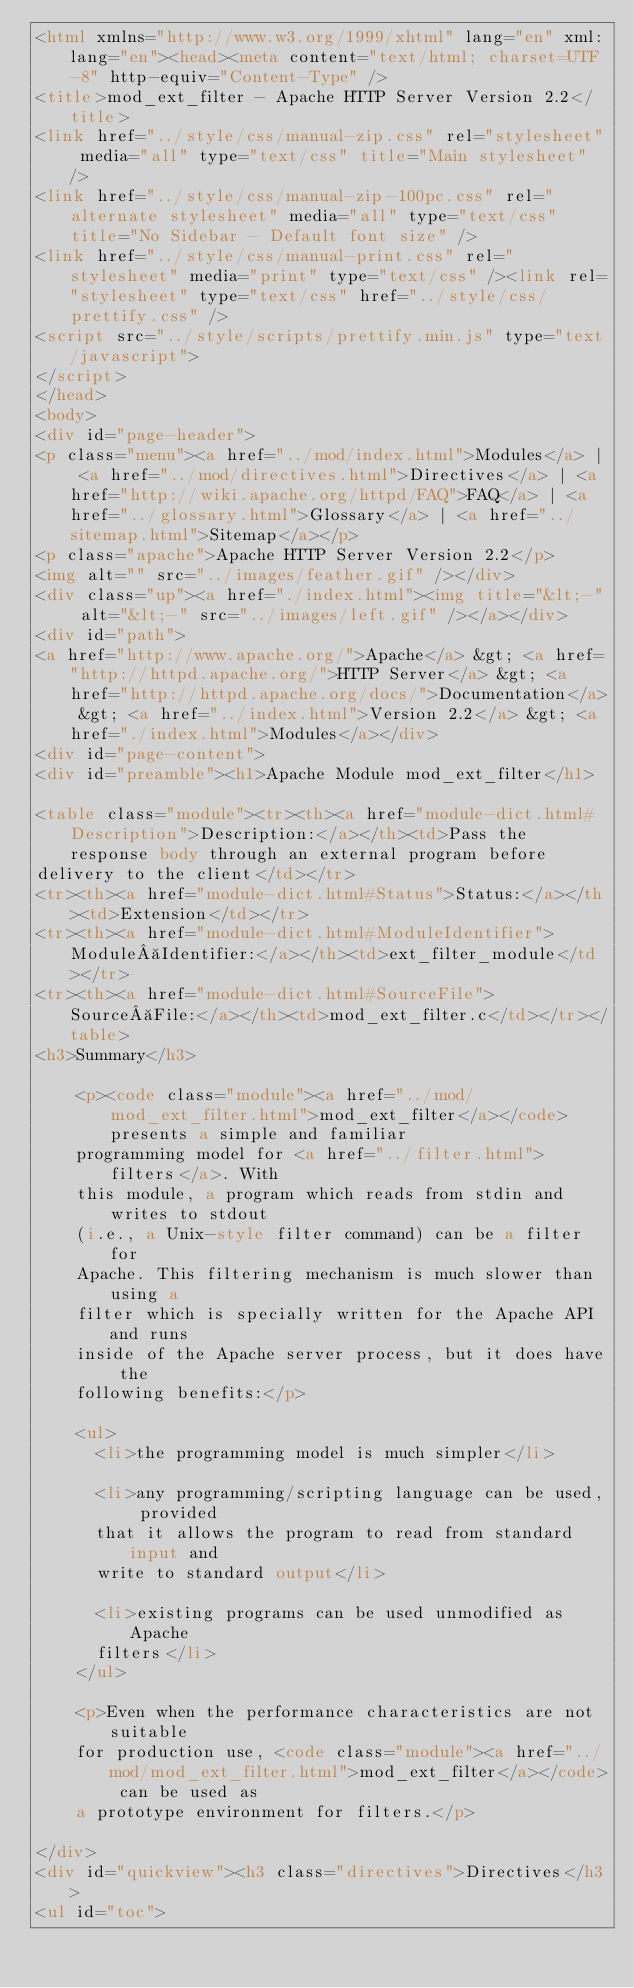Convert code to text. <code><loc_0><loc_0><loc_500><loc_500><_HTML_><html xmlns="http://www.w3.org/1999/xhtml" lang="en" xml:lang="en"><head><meta content="text/html; charset=UTF-8" http-equiv="Content-Type" />
<title>mod_ext_filter - Apache HTTP Server Version 2.2</title>
<link href="../style/css/manual-zip.css" rel="stylesheet" media="all" type="text/css" title="Main stylesheet" />
<link href="../style/css/manual-zip-100pc.css" rel="alternate stylesheet" media="all" type="text/css" title="No Sidebar - Default font size" />
<link href="../style/css/manual-print.css" rel="stylesheet" media="print" type="text/css" /><link rel="stylesheet" type="text/css" href="../style/css/prettify.css" />
<script src="../style/scripts/prettify.min.js" type="text/javascript">
</script>
</head>
<body>
<div id="page-header">
<p class="menu"><a href="../mod/index.html">Modules</a> | <a href="../mod/directives.html">Directives</a> | <a href="http://wiki.apache.org/httpd/FAQ">FAQ</a> | <a href="../glossary.html">Glossary</a> | <a href="../sitemap.html">Sitemap</a></p>
<p class="apache">Apache HTTP Server Version 2.2</p>
<img alt="" src="../images/feather.gif" /></div>
<div class="up"><a href="./index.html"><img title="&lt;-" alt="&lt;-" src="../images/left.gif" /></a></div>
<div id="path">
<a href="http://www.apache.org/">Apache</a> &gt; <a href="http://httpd.apache.org/">HTTP Server</a> &gt; <a href="http://httpd.apache.org/docs/">Documentation</a> &gt; <a href="../index.html">Version 2.2</a> &gt; <a href="./index.html">Modules</a></div>
<div id="page-content">
<div id="preamble"><h1>Apache Module mod_ext_filter</h1>

<table class="module"><tr><th><a href="module-dict.html#Description">Description:</a></th><td>Pass the response body through an external program before
delivery to the client</td></tr>
<tr><th><a href="module-dict.html#Status">Status:</a></th><td>Extension</td></tr>
<tr><th><a href="module-dict.html#ModuleIdentifier">Module Identifier:</a></th><td>ext_filter_module</td></tr>
<tr><th><a href="module-dict.html#SourceFile">Source File:</a></th><td>mod_ext_filter.c</td></tr></table>
<h3>Summary</h3>

    <p><code class="module"><a href="../mod/mod_ext_filter.html">mod_ext_filter</a></code> presents a simple and familiar
    programming model for <a href="../filter.html">filters</a>. With
    this module, a program which reads from stdin and writes to stdout
    (i.e., a Unix-style filter command) can be a filter for
    Apache. This filtering mechanism is much slower than using a
    filter which is specially written for the Apache API and runs
    inside of the Apache server process, but it does have the
    following benefits:</p>

    <ul>
      <li>the programming model is much simpler</li>

      <li>any programming/scripting language can be used, provided
      that it allows the program to read from standard input and
      write to standard output</li>

      <li>existing programs can be used unmodified as Apache
      filters</li>
    </ul>

    <p>Even when the performance characteristics are not suitable
    for production use, <code class="module"><a href="../mod/mod_ext_filter.html">mod_ext_filter</a></code> can be used as
    a prototype environment for filters.</p>

</div>
<div id="quickview"><h3 class="directives">Directives</h3>
<ul id="toc"></code> 